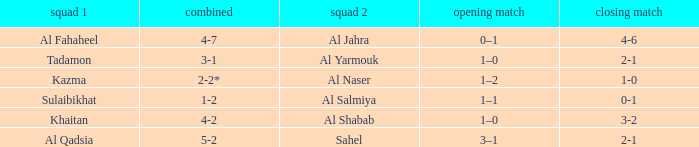What is the name of Team 2 with a Team 1 of Al Qadsia? Sahel. 